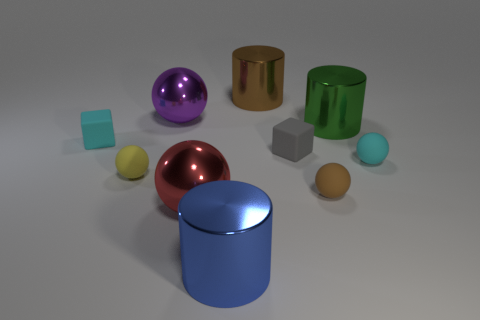What can you infer about the texture of the blue cylindrical object? The blue cylindrical object in the image has a smooth and reflective surface, suggesting it could be made of metal or polished plastic. Its even finish also gives it a clean, contemporary appearance. 